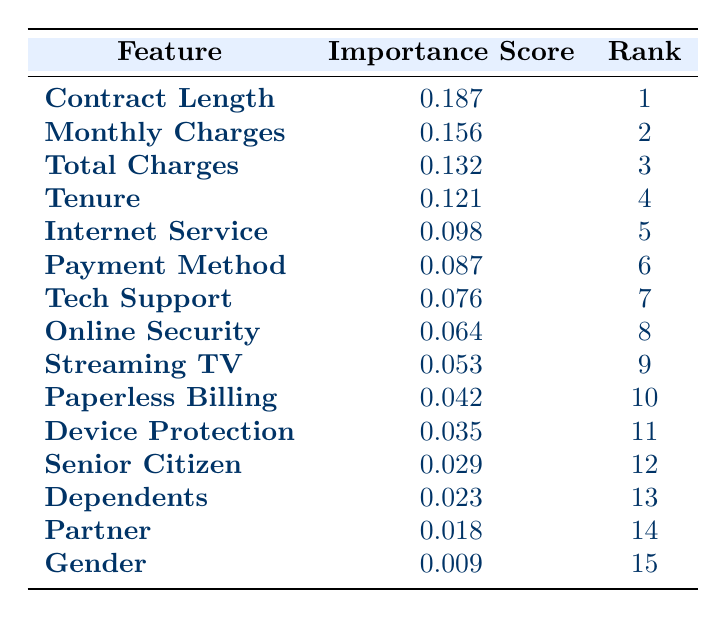What is the importance score of "Monthly Charges"? The table lists "Monthly Charges" under the "Feature" column, and the corresponding value in the "Importance Score" column is 0.156
Answer: 0.156 Which feature is ranked 4th in importance? To find the feature ranked 4th, we look for the row with rank "4" in the "Rank" column, which corresponds to "Tenure"
Answer: Tenure How many features have an importance score greater than 0.100? By scanning the "Importance Score" column, we count how many values are greater than 0.100. The features with importance scores greater than 0.100 are: "Contract Length", "Monthly Charges", "Total Charges", "Tenure", and "Internet Service", totaling 5 features
Answer: 5 What is the total importance score of the top three ranked features? We add the importance scores of the top three features: 0.187 (Contract Length) + 0.156 (Monthly Charges) + 0.132 (Total Charges) = 0.475
Answer: 0.475 Is "Gender" a more important feature than "Partner"? Comparing the importance scores, "Gender" has a score of 0.009, and "Partner" has a score of 0.018. Since 0.009 is less than 0.018, "Gender" is not more important than "Partner"
Answer: No What is the difference in importance score between the highest and lowest ranked feature? The highest ranked feature is "Contract Length" with a score of 0.187, and the lowest is "Gender" with a score of 0.009. The difference is 0.187 - 0.009 = 0.178
Answer: 0.178 Which features are in the bottom three ranks? Looking at the "Rank" column, the bottom three ranks are 13, 14, and 15, corresponding to "Dependents", "Partner", and "Gender"
Answer: Dependents, Partner, Gender Among the top five features, how many are related to service types (like Internet Service and Tech Support)? In the top five features, we look for service-related features. "Internet Service" and "Tech Support" are the only ones considered service types, making it a total of 2
Answer: 2 What is the average importance score of all features listed? We sum the importance scores of all features: 0.187 + 0.156 + 0.132 + 0.121 + 0.098 + 0.087 + 0.076 + 0.064 + 0.053 + 0.042 + 0.035 + 0.029 + 0.023 + 0.018 + 0.009 = 1.084. Dividing by the number of features (15), the average score is 1.084 / 15 = approximately 0.0723
Answer: 0.0723 